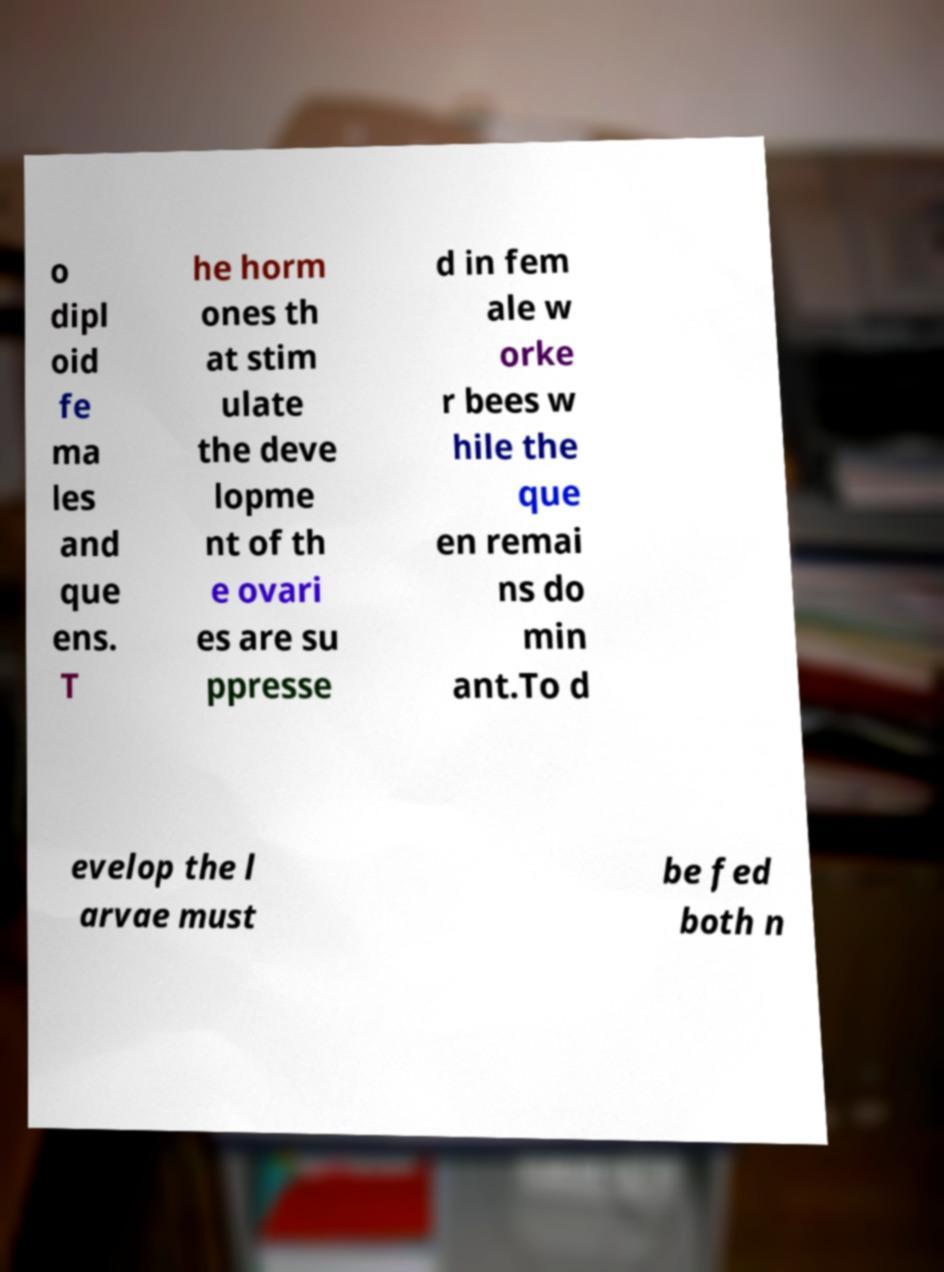Please read and relay the text visible in this image. What does it say? o dipl oid fe ma les and que ens. T he horm ones th at stim ulate the deve lopme nt of th e ovari es are su ppresse d in fem ale w orke r bees w hile the que en remai ns do min ant.To d evelop the l arvae must be fed both n 